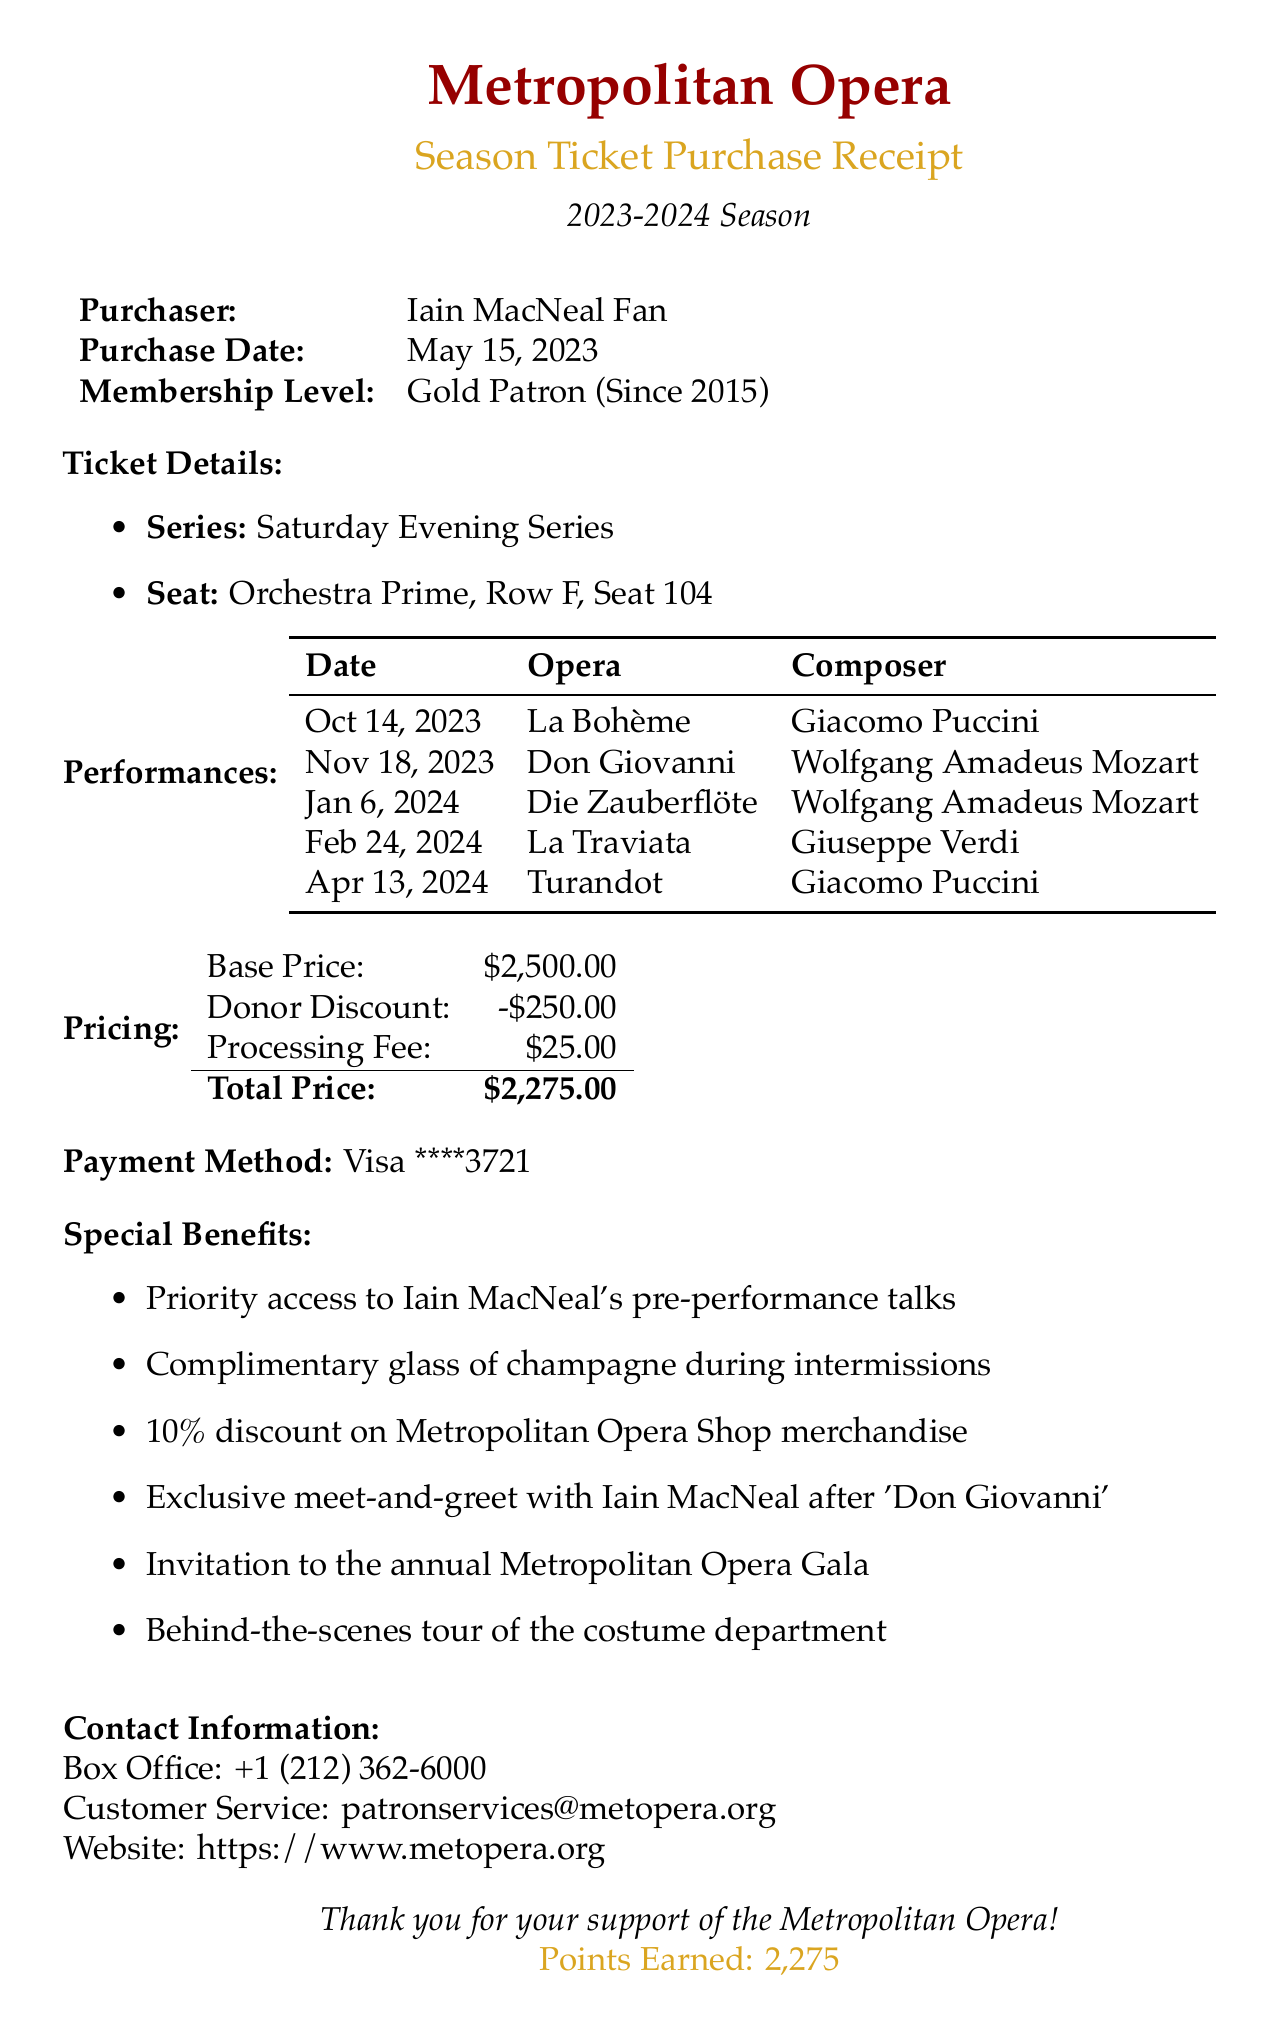What is the purchaser's name? The document specifies the name of the purchaser as "Iain MacNeal Fan".
Answer: Iain MacNeal Fan What is the total price? The total price after applying discounts and fees is stated in the pricing section as $2,275.00.
Answer: $2,275.00 What is the opera scheduled for January 6, 2024? The performances table lists "Die Zauberflöte" as the opera scheduled for that date.
Answer: Die Zauberflöte What membership level does the purchaser hold? The document indicates the membership level as "Gold Patron".
Answer: Gold Patron How many points were earned with this purchase? The document notes that the points earned from this transaction are 2,275.
Answer: 2,275 When was the purchase made? The purchase date mentioned in the document is May 15, 2023.
Answer: May 15, 2023 Which performance offers a complimentary glass of champagne? The special benefits state that a complimentary glass of champagne is included during intermissions for all performances.
Answer: All performances Who composed "La Traviata"? The document specifies that "La Traviata" was composed by Giuseppe Verdi.
Answer: Giuseppe Verdi What special access is included with the tickets? The special notes mention "priority access to Iain MacNeal's pre-performance talks".
Answer: Priority access to Iain MacNeal's pre-performance talks 